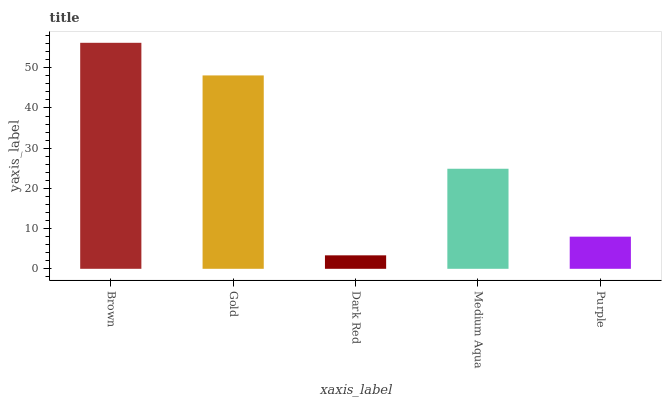Is Dark Red the minimum?
Answer yes or no. Yes. Is Brown the maximum?
Answer yes or no. Yes. Is Gold the minimum?
Answer yes or no. No. Is Gold the maximum?
Answer yes or no. No. Is Brown greater than Gold?
Answer yes or no. Yes. Is Gold less than Brown?
Answer yes or no. Yes. Is Gold greater than Brown?
Answer yes or no. No. Is Brown less than Gold?
Answer yes or no. No. Is Medium Aqua the high median?
Answer yes or no. Yes. Is Medium Aqua the low median?
Answer yes or no. Yes. Is Brown the high median?
Answer yes or no. No. Is Brown the low median?
Answer yes or no. No. 